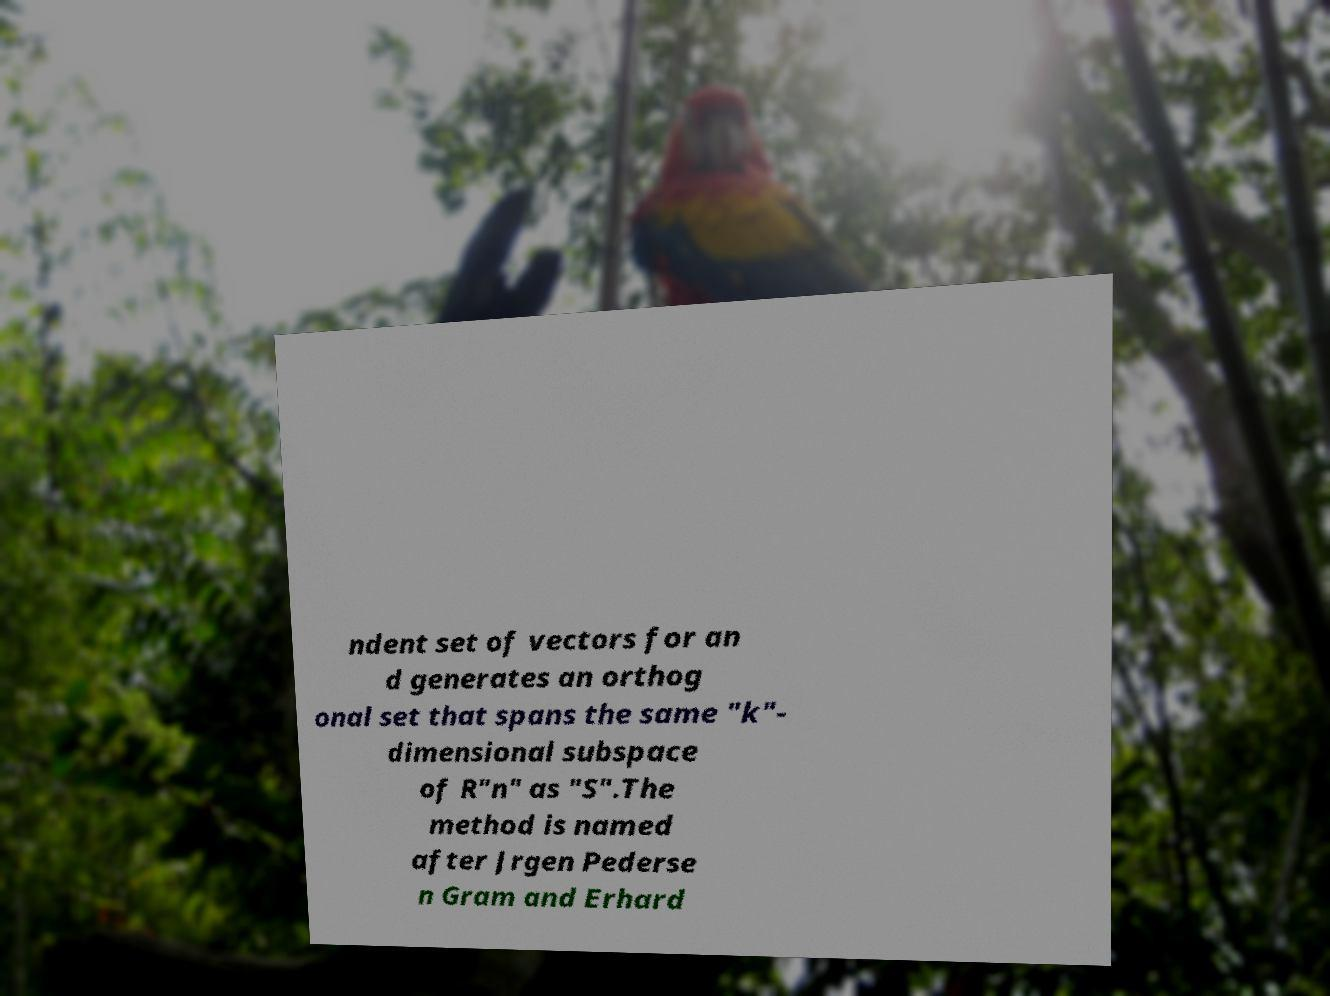Can you read and provide the text displayed in the image?This photo seems to have some interesting text. Can you extract and type it out for me? ndent set of vectors for an d generates an orthog onal set that spans the same "k"- dimensional subspace of R"n" as "S".The method is named after Jrgen Pederse n Gram and Erhard 